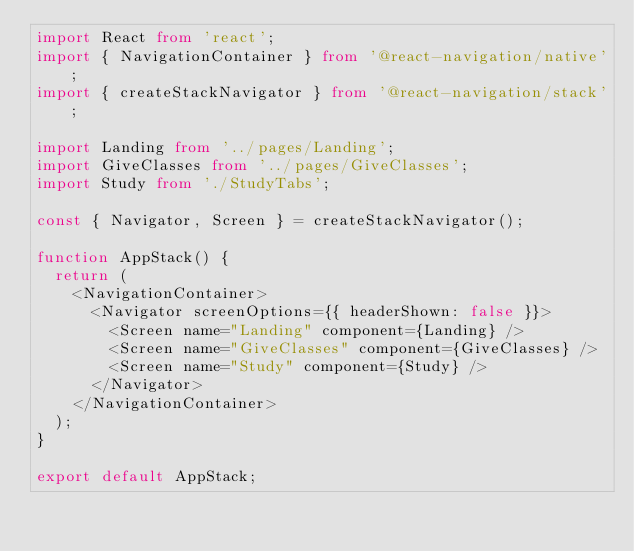Convert code to text. <code><loc_0><loc_0><loc_500><loc_500><_TypeScript_>import React from 'react';
import { NavigationContainer } from '@react-navigation/native';
import { createStackNavigator } from '@react-navigation/stack';

import Landing from '../pages/Landing';
import GiveClasses from '../pages/GiveClasses';
import Study from './StudyTabs';

const { Navigator, Screen } = createStackNavigator();

function AppStack() {
  return (
    <NavigationContainer>
      <Navigator screenOptions={{ headerShown: false }}>
        <Screen name="Landing" component={Landing} />
        <Screen name="GiveClasses" component={GiveClasses} />
        <Screen name="Study" component={Study} />
      </Navigator>
    </NavigationContainer>
  );
}

export default AppStack;
</code> 